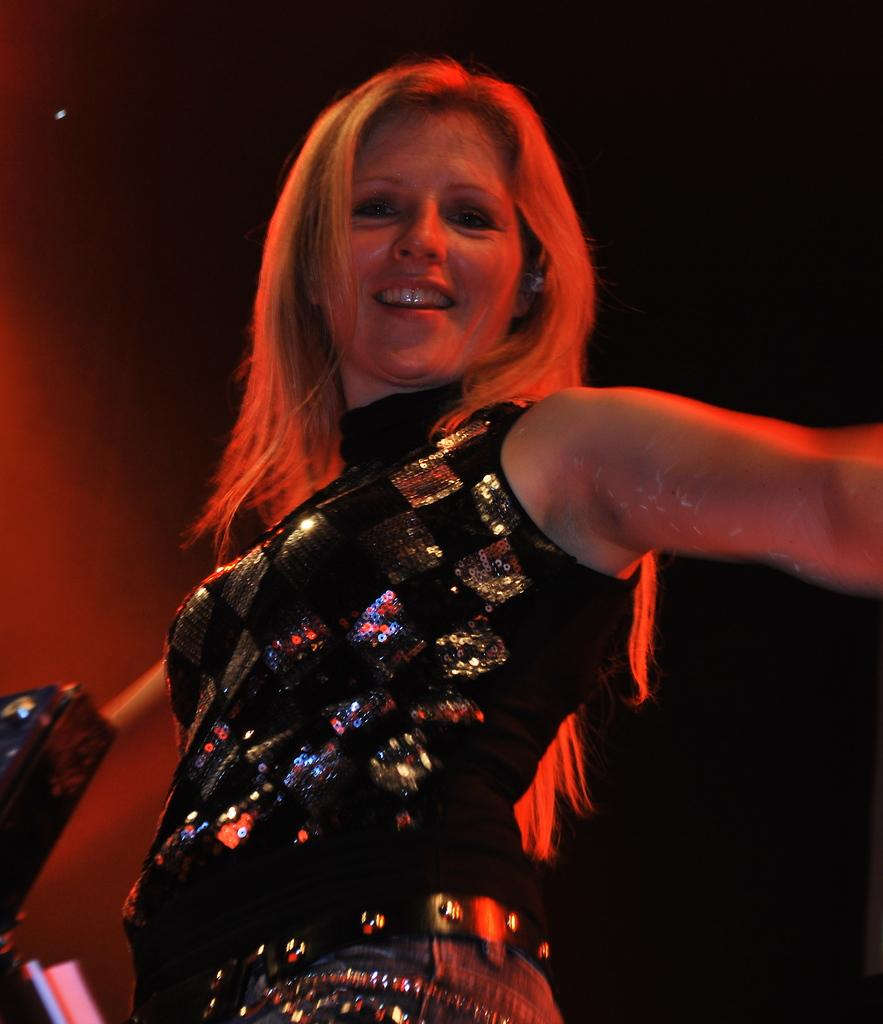Who is the main subject in the image? There is a woman in the image. What is the woman wearing? The woman is wearing a black dress. What is the woman doing in the image? The woman appears to be dancing. What can be observed about the background of the image? The background of the image is dark. What does the woman's father think about her dancing in the image? There is no information about the woman's father or his opinion in the image. What is the woman's desire while dancing in the image? There is no information about the woman's desires or emotions in the image. 